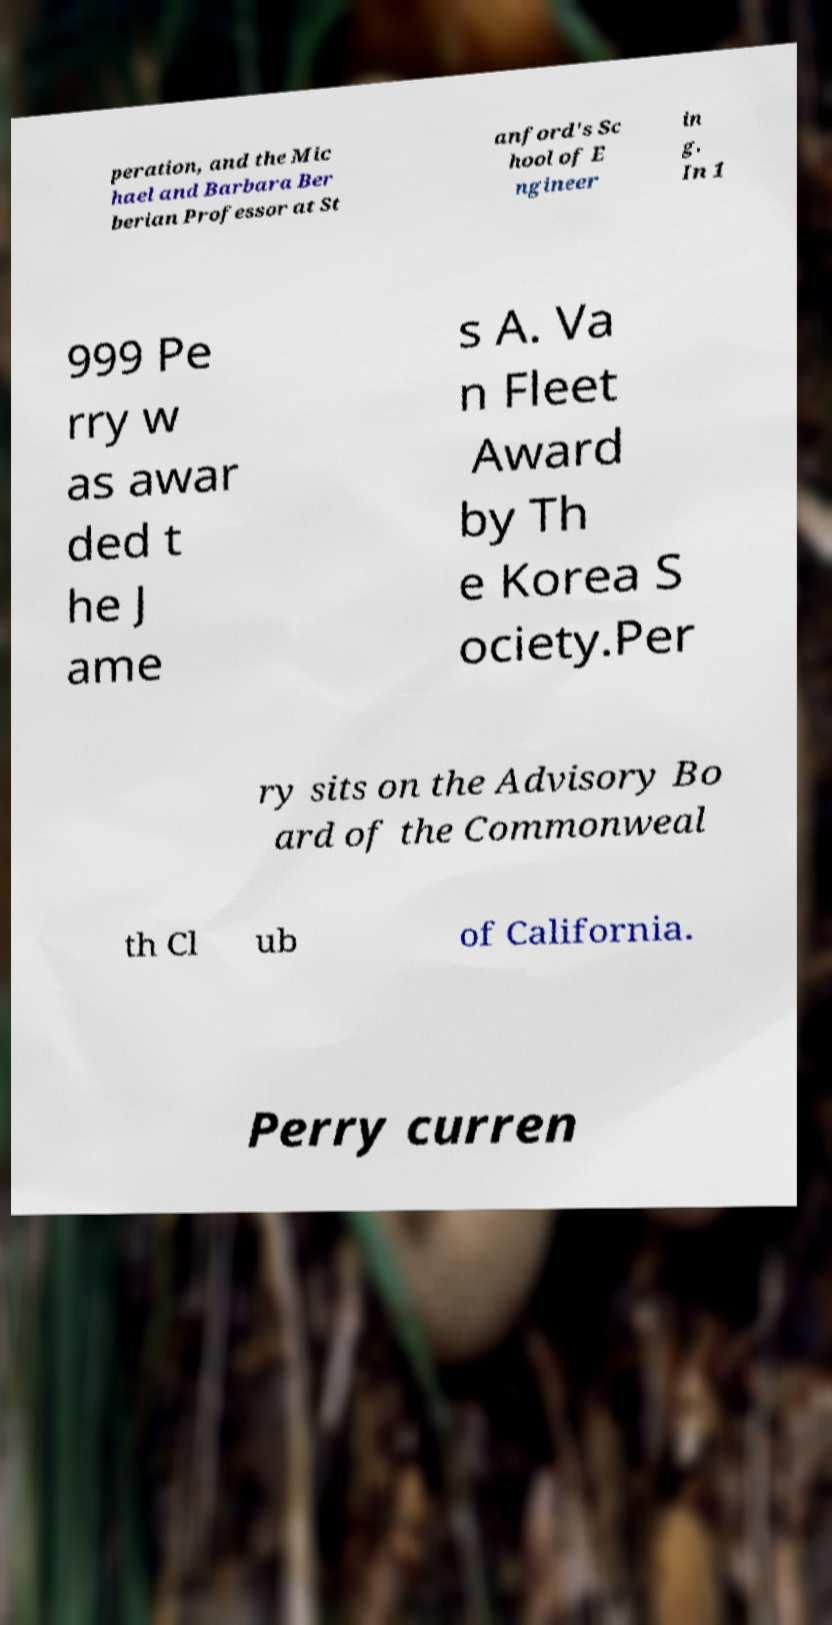Please identify and transcribe the text found in this image. peration, and the Mic hael and Barbara Ber berian Professor at St anford's Sc hool of E ngineer in g. In 1 999 Pe rry w as awar ded t he J ame s A. Va n Fleet Award by Th e Korea S ociety.Per ry sits on the Advisory Bo ard of the Commonweal th Cl ub of California. Perry curren 